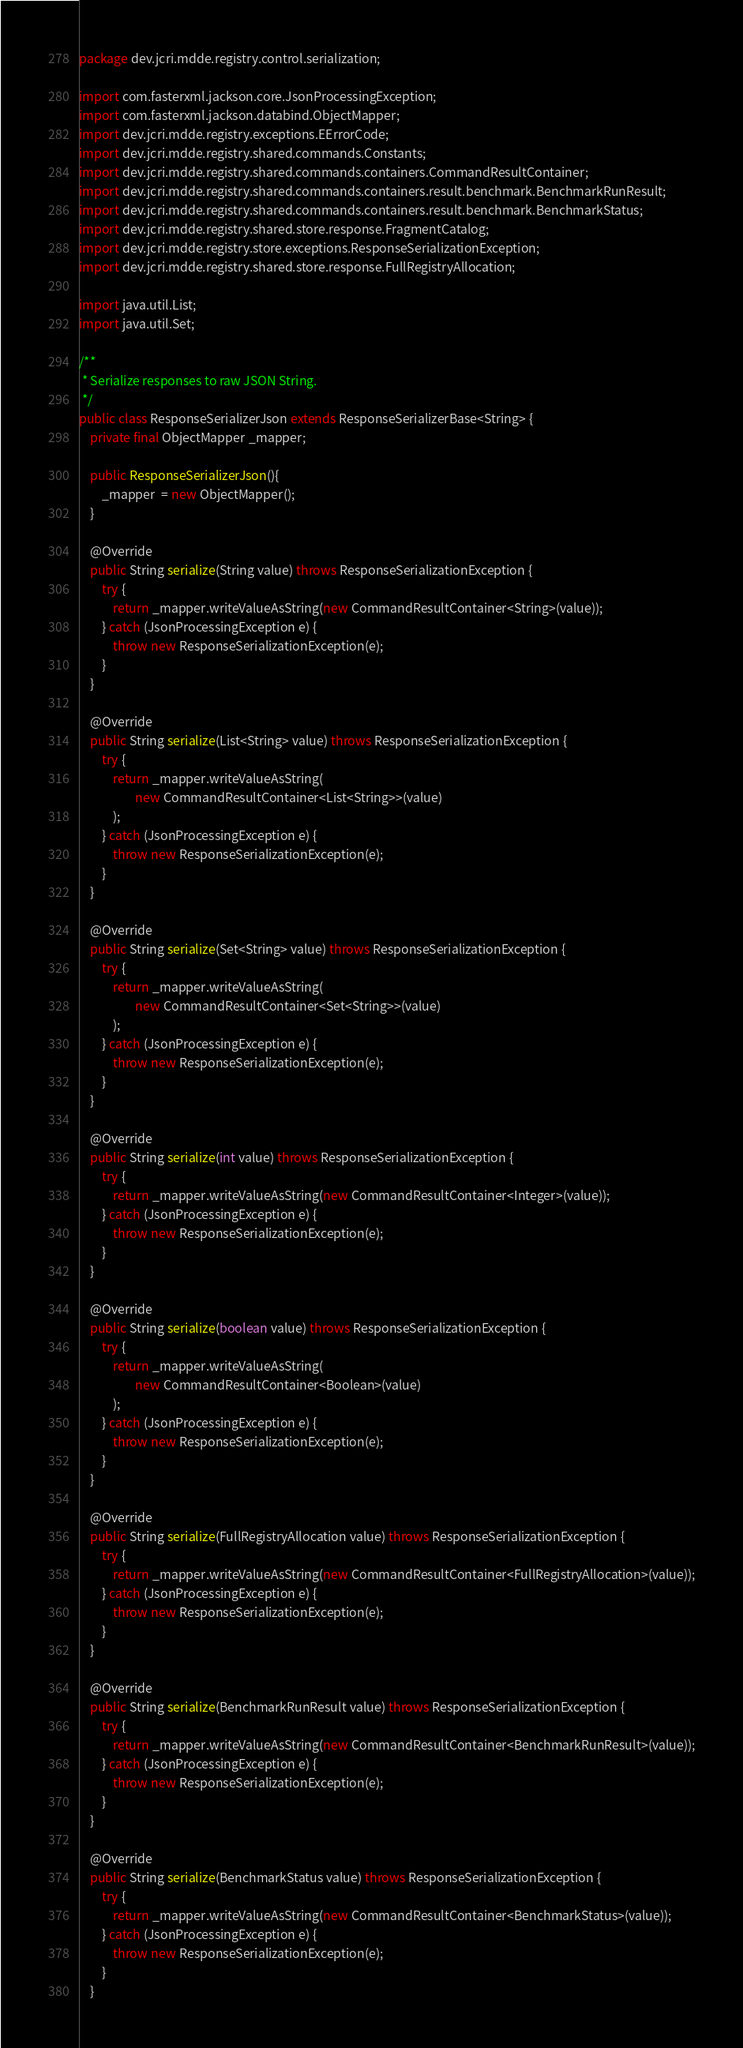<code> <loc_0><loc_0><loc_500><loc_500><_Java_>package dev.jcri.mdde.registry.control.serialization;

import com.fasterxml.jackson.core.JsonProcessingException;
import com.fasterxml.jackson.databind.ObjectMapper;
import dev.jcri.mdde.registry.exceptions.EErrorCode;
import dev.jcri.mdde.registry.shared.commands.Constants;
import dev.jcri.mdde.registry.shared.commands.containers.CommandResultContainer;
import dev.jcri.mdde.registry.shared.commands.containers.result.benchmark.BenchmarkRunResult;
import dev.jcri.mdde.registry.shared.commands.containers.result.benchmark.BenchmarkStatus;
import dev.jcri.mdde.registry.shared.store.response.FragmentCatalog;
import dev.jcri.mdde.registry.store.exceptions.ResponseSerializationException;
import dev.jcri.mdde.registry.shared.store.response.FullRegistryAllocation;

import java.util.List;
import java.util.Set;

/**
 * Serialize responses to raw JSON String.
 */
public class ResponseSerializerJson extends ResponseSerializerBase<String> {
    private final ObjectMapper _mapper;

    public ResponseSerializerJson(){
        _mapper  = new ObjectMapper();
    }

    @Override
    public String serialize(String value) throws ResponseSerializationException {
        try {
            return _mapper.writeValueAsString(new CommandResultContainer<String>(value));
        } catch (JsonProcessingException e) {
            throw new ResponseSerializationException(e);
        }
    }

    @Override
    public String serialize(List<String> value) throws ResponseSerializationException {
        try {
            return _mapper.writeValueAsString(
                    new CommandResultContainer<List<String>>(value)
            );
        } catch (JsonProcessingException e) {
            throw new ResponseSerializationException(e);
        }
    }

    @Override
    public String serialize(Set<String> value) throws ResponseSerializationException {
        try {
            return _mapper.writeValueAsString(
                    new CommandResultContainer<Set<String>>(value)
            );
        } catch (JsonProcessingException e) {
            throw new ResponseSerializationException(e);
        }
    }

    @Override
    public String serialize(int value) throws ResponseSerializationException {
        try {
            return _mapper.writeValueAsString(new CommandResultContainer<Integer>(value));
        } catch (JsonProcessingException e) {
            throw new ResponseSerializationException(e);
        }
    }

    @Override
    public String serialize(boolean value) throws ResponseSerializationException {
        try {
            return _mapper.writeValueAsString(
                    new CommandResultContainer<Boolean>(value)
            );
        } catch (JsonProcessingException e) {
            throw new ResponseSerializationException(e);
        }
    }

    @Override
    public String serialize(FullRegistryAllocation value) throws ResponseSerializationException {
        try {
            return _mapper.writeValueAsString(new CommandResultContainer<FullRegistryAllocation>(value));
        } catch (JsonProcessingException e) {
            throw new ResponseSerializationException(e);
        }
    }

    @Override
    public String serialize(BenchmarkRunResult value) throws ResponseSerializationException {
        try {
            return _mapper.writeValueAsString(new CommandResultContainer<BenchmarkRunResult>(value));
        } catch (JsonProcessingException e) {
            throw new ResponseSerializationException(e);
        }
    }

    @Override
    public String serialize(BenchmarkStatus value) throws ResponseSerializationException {
        try {
            return _mapper.writeValueAsString(new CommandResultContainer<BenchmarkStatus>(value));
        } catch (JsonProcessingException e) {
            throw new ResponseSerializationException(e);
        }
    }
</code> 